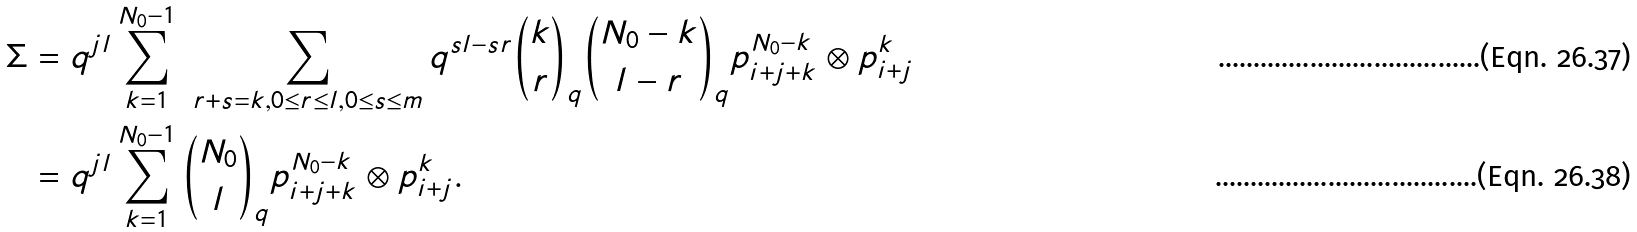<formula> <loc_0><loc_0><loc_500><loc_500>\Sigma & = q ^ { j l } \sum _ { k = 1 } ^ { N _ { 0 } - 1 } \ \sum _ { r + s = k , 0 \leq r \leq l , 0 \leq s \leq m } q ^ { s l - s r } { k \choose r } _ { q } { N _ { 0 } - k \choose l - r } _ { q } p _ { i + j + k } ^ { N _ { 0 } - k } \otimes p _ { i + j } ^ { k } \\ & = q ^ { j l } \sum _ { k = 1 } ^ { N _ { 0 } - 1 } { N _ { 0 } \choose l } _ { q } p _ { i + j + k } ^ { N _ { 0 } - k } \otimes p _ { i + j } ^ { k } .</formula> 